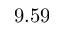<formula> <loc_0><loc_0><loc_500><loc_500>9 . 5 9</formula> 